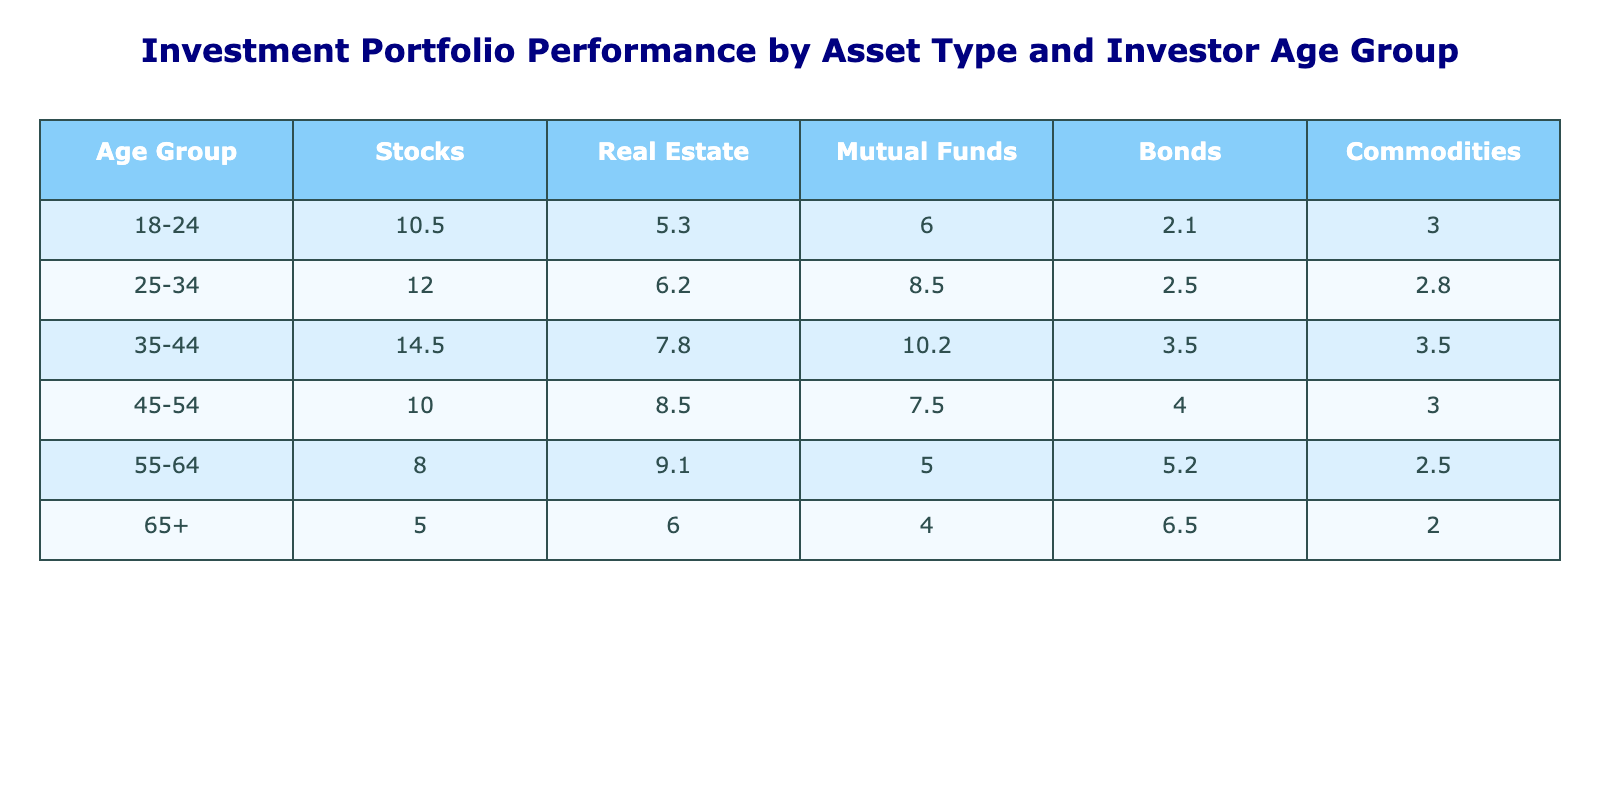What is the percentage of investment in Stocks for the age group 35-44? The table shows the investment percentage for the age group 35-44 under Stocks, which is 14.5.
Answer: 14.5 Which asset type has the highest investment percentage for the age group 55-64? In the row for the age group 55-64, the values for each asset type are: Stocks (8.0), Real Estate (9.1), Mutual Funds (5.0), Bonds (5.2), and Commodities (2.5). The highest value is for Real Estate at 9.1.
Answer: Real Estate Is it true that investors aged 25-34 invest more in Bonds than in Commodities? The investment percentages for Bonds and Commodities for the age group 25-34 are 2.5 and 2.8 respectively. Since 2.5 is less than 2.8, the statement is false.
Answer: No What is the total investment percentage in Mutual Funds across all age groups? To find the total, we sum the Mutual Funds percentages for each age group: 6.0 (18-24) + 8.5 (25-34) + 10.2 (35-44) + 7.5 (45-54) + 5.0 (55-64) + 4.0 (65+) = 41.2.
Answer: 41.2 For which age group is the investment in Bonds the highest? Looking at the Bonds column, the ages group 65+ has the highest investment percentage of 6.5, compared to the others (2.1 for 18-24, 2.5 for 25-34, 3.5 for 35-44, 4.0 for 45-54, and 5.2 for 55-64).
Answer: 65+ 